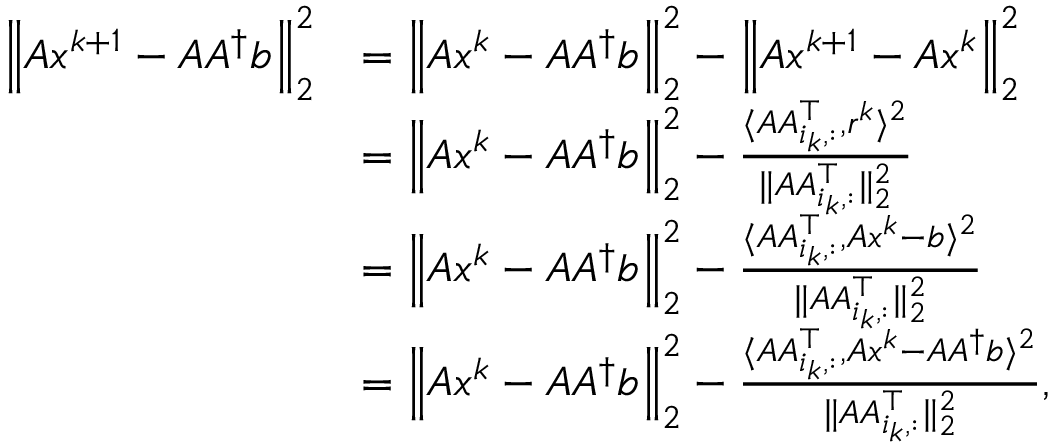Convert formula to latex. <formula><loc_0><loc_0><loc_500><loc_500>\begin{array} { r l } { \left \| A x ^ { k + 1 } - A A ^ { \dagger } b \right \| _ { 2 } ^ { 2 } } & { = \left \| A x ^ { k } - A A ^ { \dagger } b \right \| _ { 2 } ^ { 2 } - \left \| A x ^ { k + 1 } - A x ^ { k } \right \| _ { 2 } ^ { 2 } } \\ & { = \left \| A x ^ { k } - A A ^ { \dagger } b \right \| _ { 2 } ^ { 2 } - \frac { \langle A A _ { i _ { k } , \colon } ^ { \top } , r ^ { k } \rangle ^ { 2 } } { \| A A _ { i _ { k } , \colon } ^ { \top } \| _ { 2 } ^ { 2 } } } \\ & { = \left \| A x ^ { k } - A A ^ { \dagger } b \right \| _ { 2 } ^ { 2 } - \frac { \langle A A _ { i _ { k } , \colon } ^ { \top } , A x ^ { k } - b \rangle ^ { 2 } } { \| A A _ { i _ { k } , \colon } ^ { \top } \| _ { 2 } ^ { 2 } } } \\ & { = \left \| A x ^ { k } - A A ^ { \dagger } b \right \| _ { 2 } ^ { 2 } - \frac { \langle A A _ { i _ { k } , \colon } ^ { \top } , A x ^ { k } - A A ^ { \dagger } b \rangle ^ { 2 } } { \| A A _ { i _ { k } , \colon } ^ { \top } \| _ { 2 } ^ { 2 } } , } \end{array}</formula> 